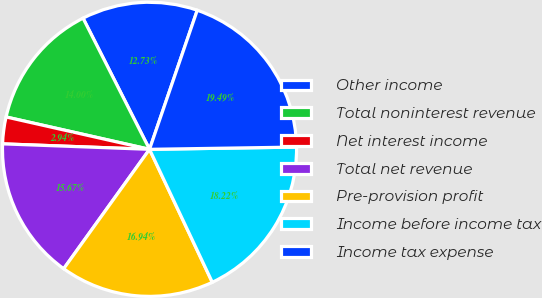Convert chart to OTSL. <chart><loc_0><loc_0><loc_500><loc_500><pie_chart><fcel>Other income<fcel>Total noninterest revenue<fcel>Net interest income<fcel>Total net revenue<fcel>Pre-provision profit<fcel>Income before income tax<fcel>Income tax expense<nl><fcel>12.73%<fcel>14.0%<fcel>2.94%<fcel>15.67%<fcel>16.94%<fcel>18.22%<fcel>19.49%<nl></chart> 